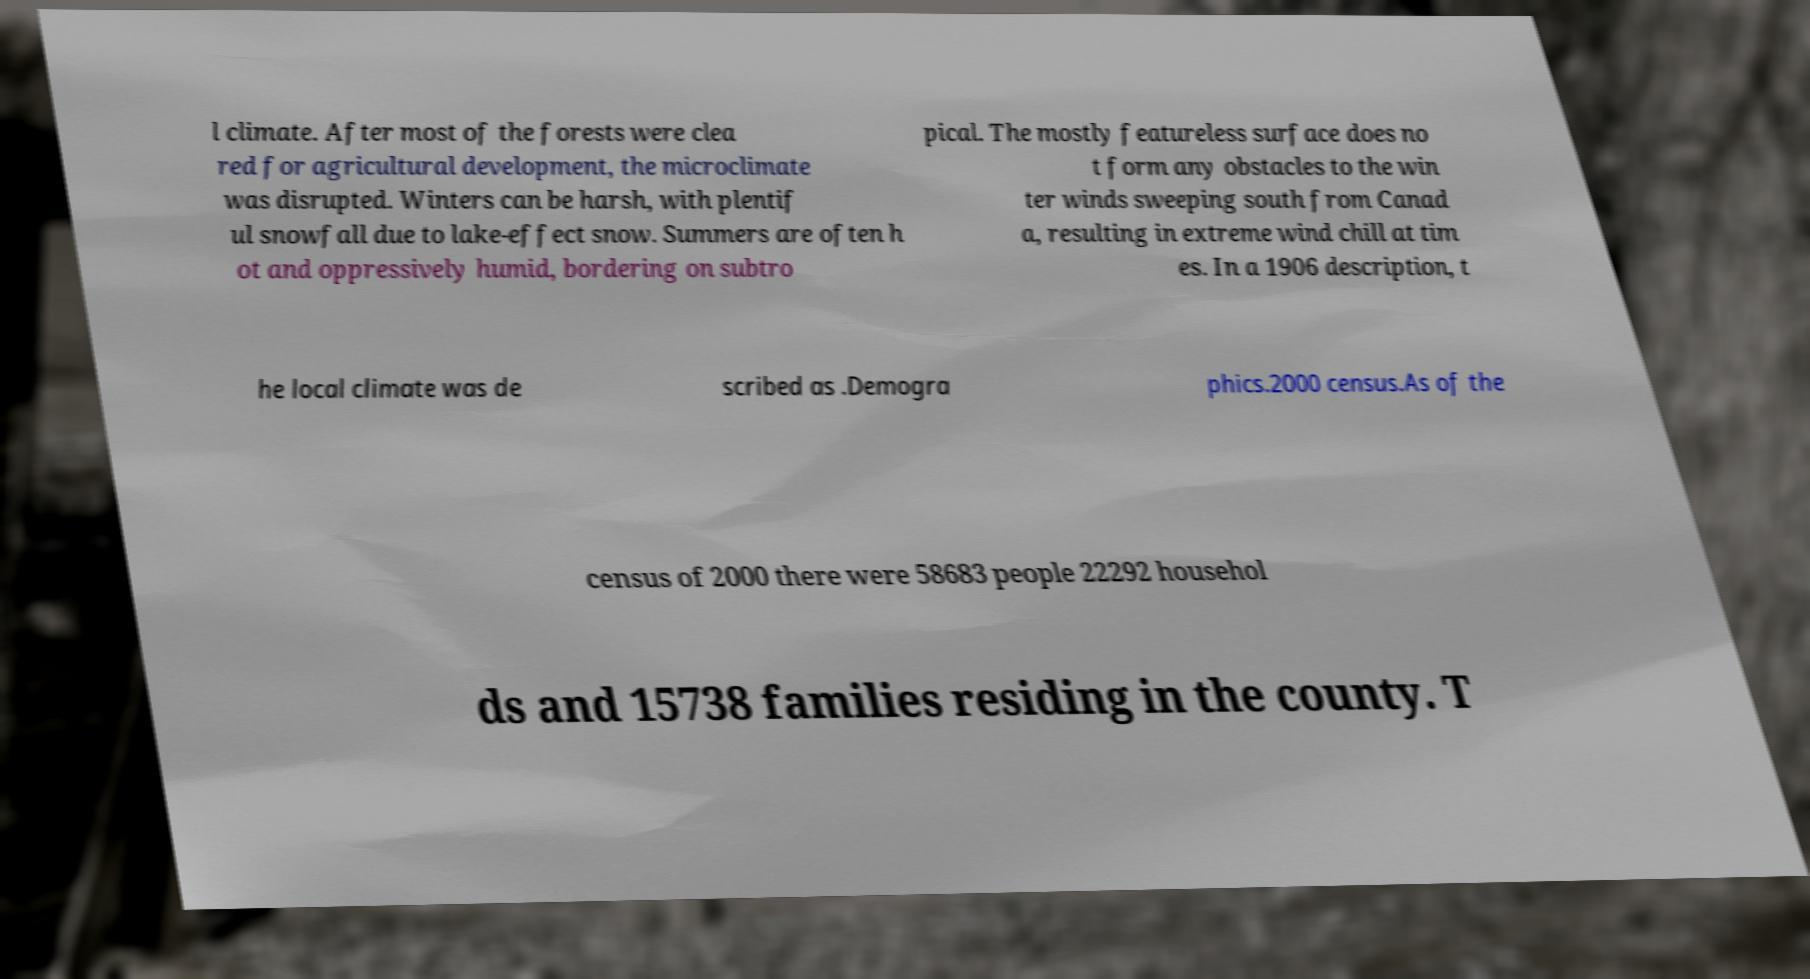Can you accurately transcribe the text from the provided image for me? l climate. After most of the forests were clea red for agricultural development, the microclimate was disrupted. Winters can be harsh, with plentif ul snowfall due to lake-effect snow. Summers are often h ot and oppressively humid, bordering on subtro pical. The mostly featureless surface does no t form any obstacles to the win ter winds sweeping south from Canad a, resulting in extreme wind chill at tim es. In a 1906 description, t he local climate was de scribed as .Demogra phics.2000 census.As of the census of 2000 there were 58683 people 22292 househol ds and 15738 families residing in the county. T 